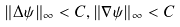Convert formula to latex. <formula><loc_0><loc_0><loc_500><loc_500>\| \Delta \psi \| _ { \infty } < C , \| \nabla \psi \| _ { \infty } < C</formula> 